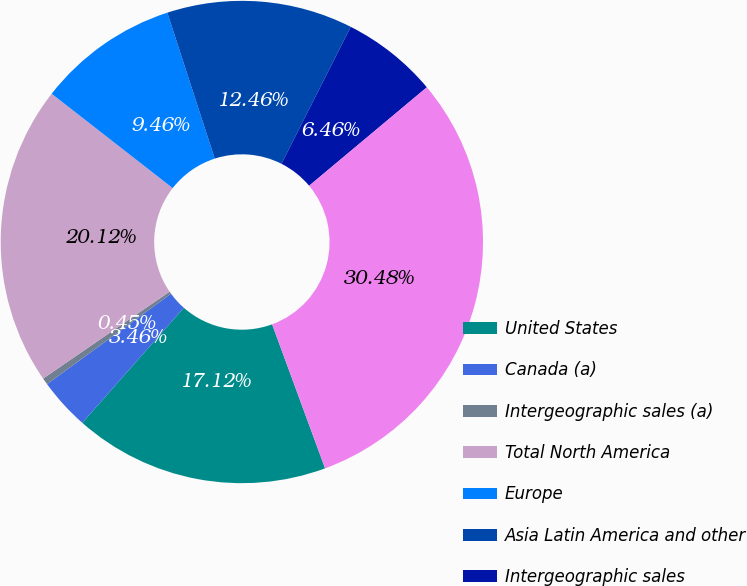<chart> <loc_0><loc_0><loc_500><loc_500><pie_chart><fcel>United States<fcel>Canada (a)<fcel>Intergeographic sales (a)<fcel>Total North America<fcel>Europe<fcel>Asia Latin America and other<fcel>Intergeographic sales<fcel>Consolidated<nl><fcel>17.12%<fcel>3.46%<fcel>0.45%<fcel>20.12%<fcel>9.46%<fcel>12.46%<fcel>6.46%<fcel>30.48%<nl></chart> 